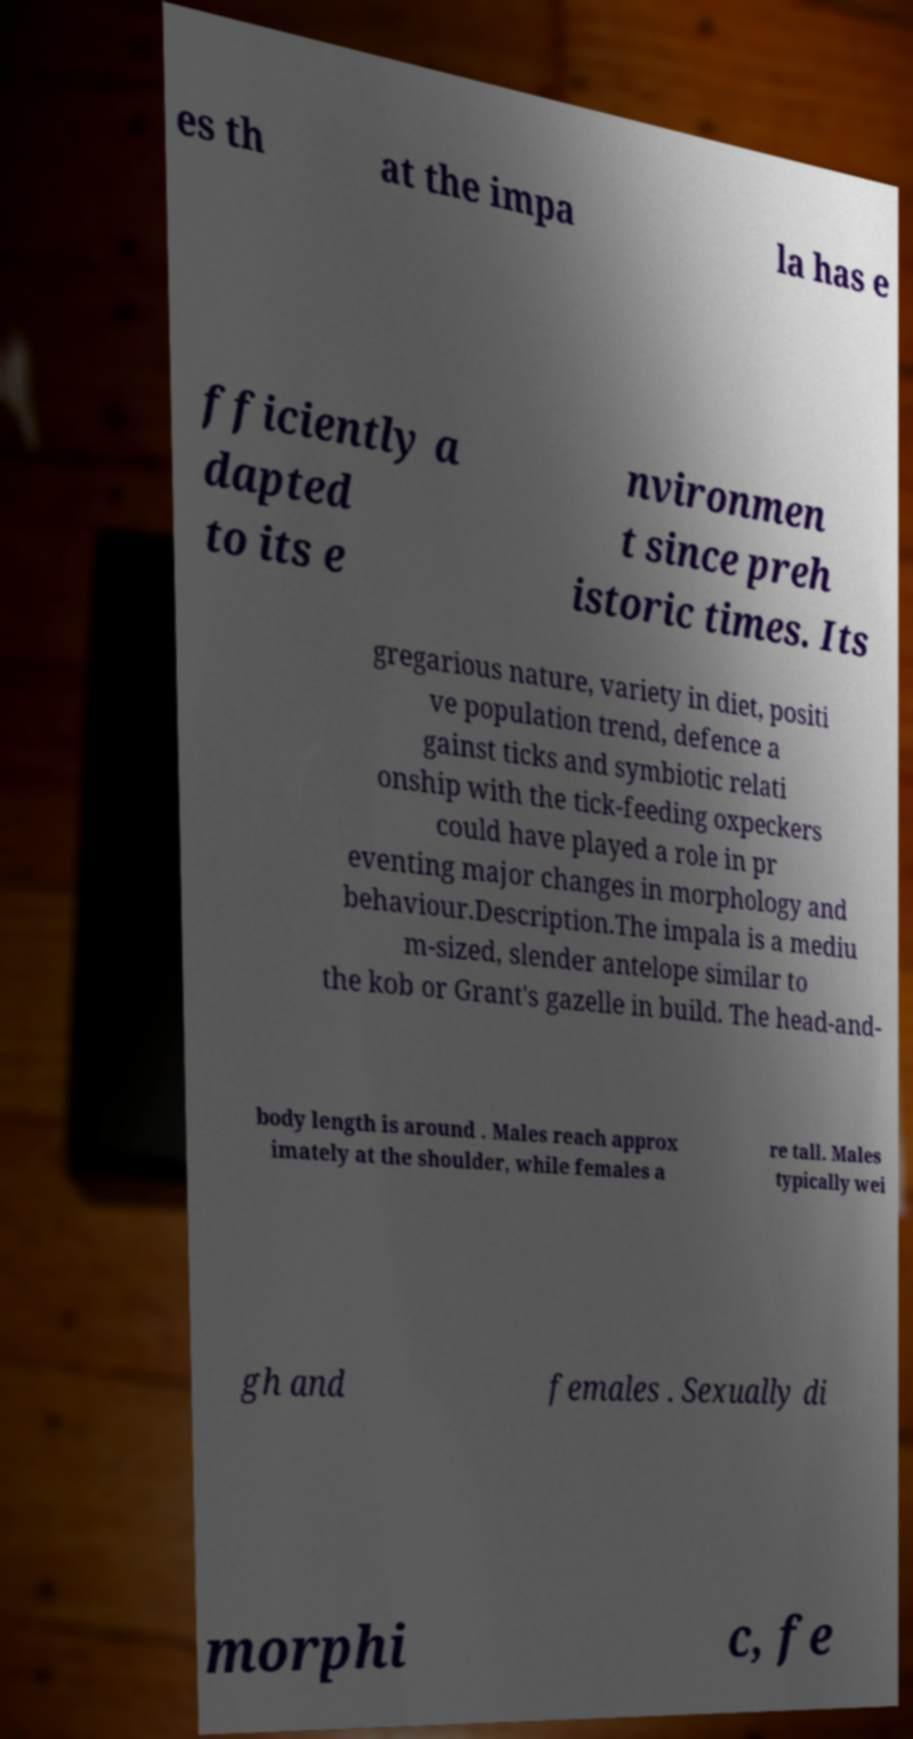Please identify and transcribe the text found in this image. es th at the impa la has e fficiently a dapted to its e nvironmen t since preh istoric times. Its gregarious nature, variety in diet, positi ve population trend, defence a gainst ticks and symbiotic relati onship with the tick-feeding oxpeckers could have played a role in pr eventing major changes in morphology and behaviour.Description.The impala is a mediu m-sized, slender antelope similar to the kob or Grant's gazelle in build. The head-and- body length is around . Males reach approx imately at the shoulder, while females a re tall. Males typically wei gh and females . Sexually di morphi c, fe 